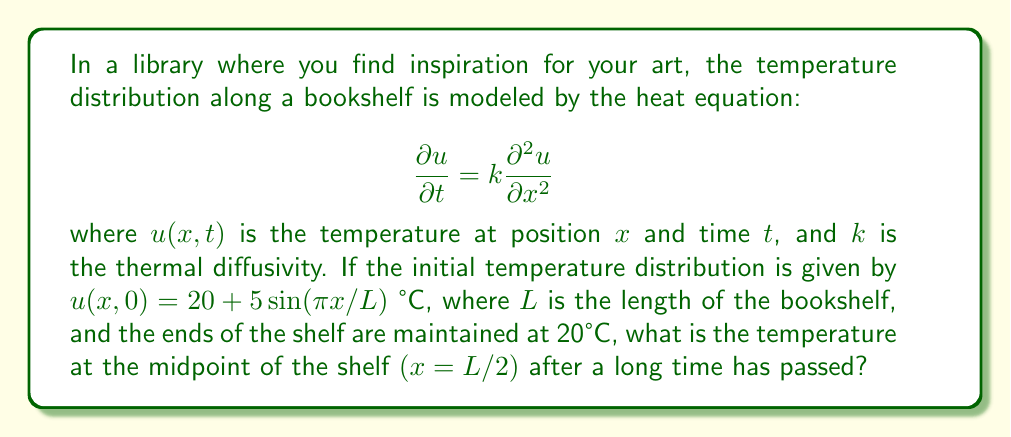Can you solve this math problem? Let's approach this step-by-step:

1) The general solution to the heat equation with these boundary conditions is:

   $$u(x,t) = 20 + \sum_{n=1}^{\infty} B_n \sin(\frac{n\pi x}{L})e^{-k(\frac{n\pi}{L})^2t}$$

2) The initial condition is:
   
   $$u(x,0) = 20 + 5\sin(\frac{\pi x}{L})$$

3) Comparing this with the general solution, we see that only the $n=1$ term is present in the initial condition. So, $B_1 = 5$ and all other $B_n = 0$.

4) Therefore, our specific solution is:

   $$u(x,t) = 20 + 5\sin(\frac{\pi x}{L})e^{-k(\frac{\pi}{L})^2t}$$

5) As time passes $(t \to \infty)$, the exponential term approaches zero:

   $$\lim_{t \to \infty} e^{-k(\frac{\pi}{L})^2t} = 0$$

6) This means that after a long time, the temperature distribution becomes:

   $$\lim_{t \to \infty} u(x,t) = 20$$

7) At the midpoint of the shelf $(x=L/2)$, the temperature will also approach 20°C.
Answer: 20°C 